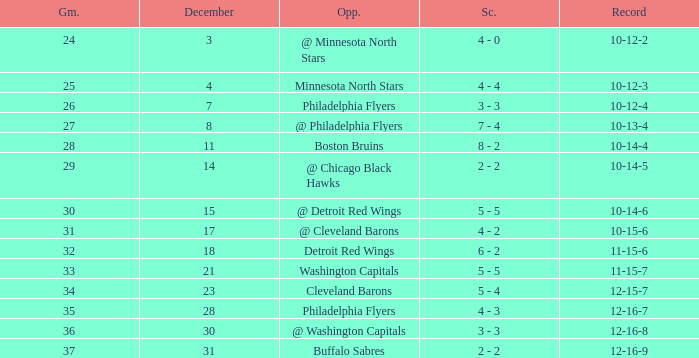What is Opponent, when Game is "37"? Buffalo Sabres. 